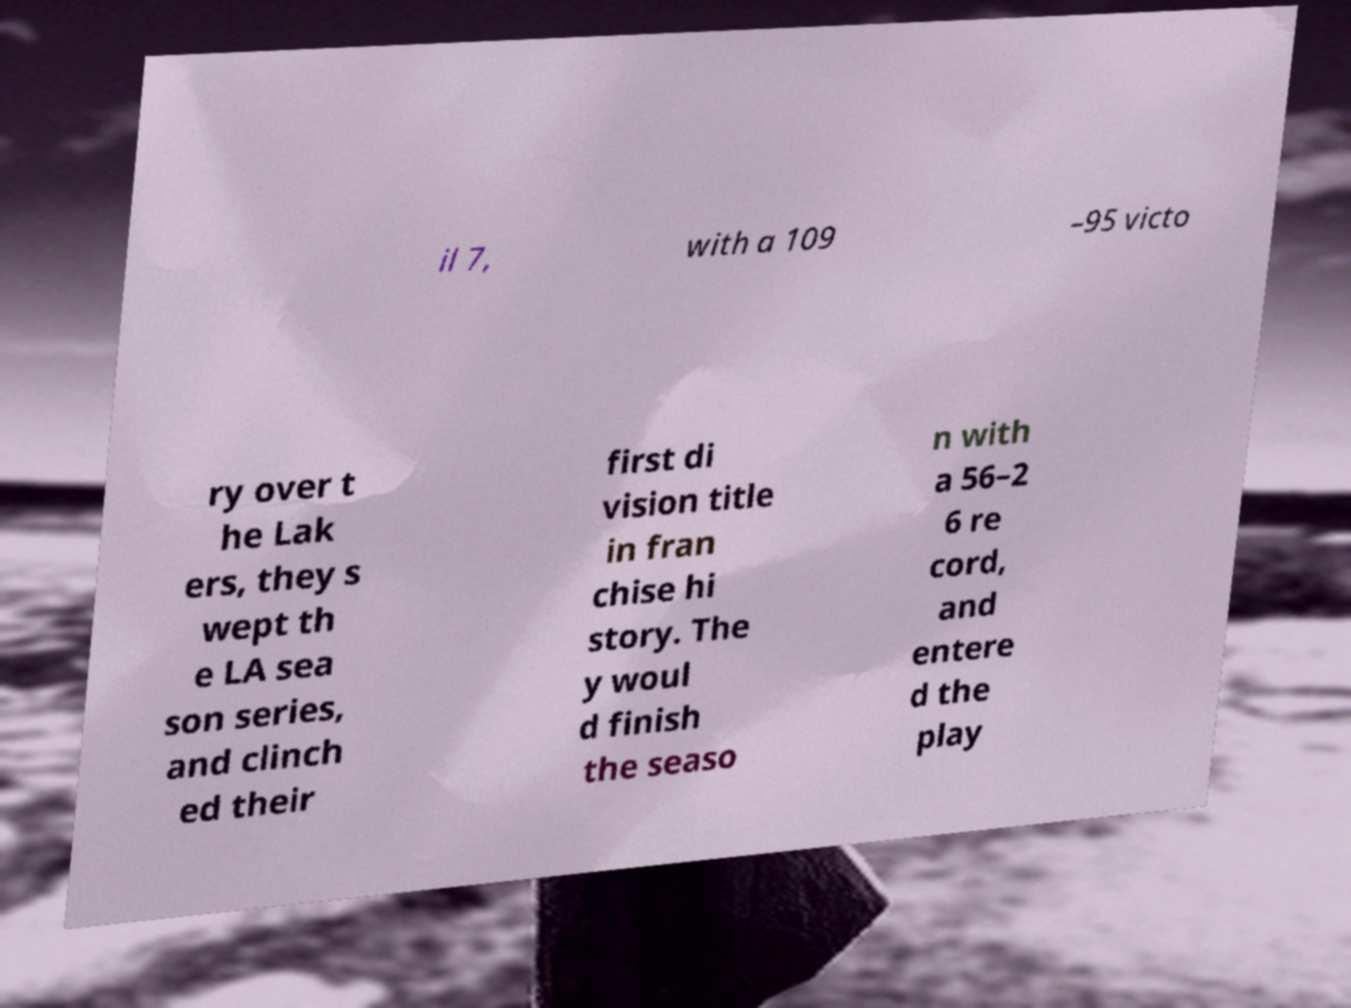I need the written content from this picture converted into text. Can you do that? il 7, with a 109 –95 victo ry over t he Lak ers, they s wept th e LA sea son series, and clinch ed their first di vision title in fran chise hi story. The y woul d finish the seaso n with a 56–2 6 re cord, and entere d the play 